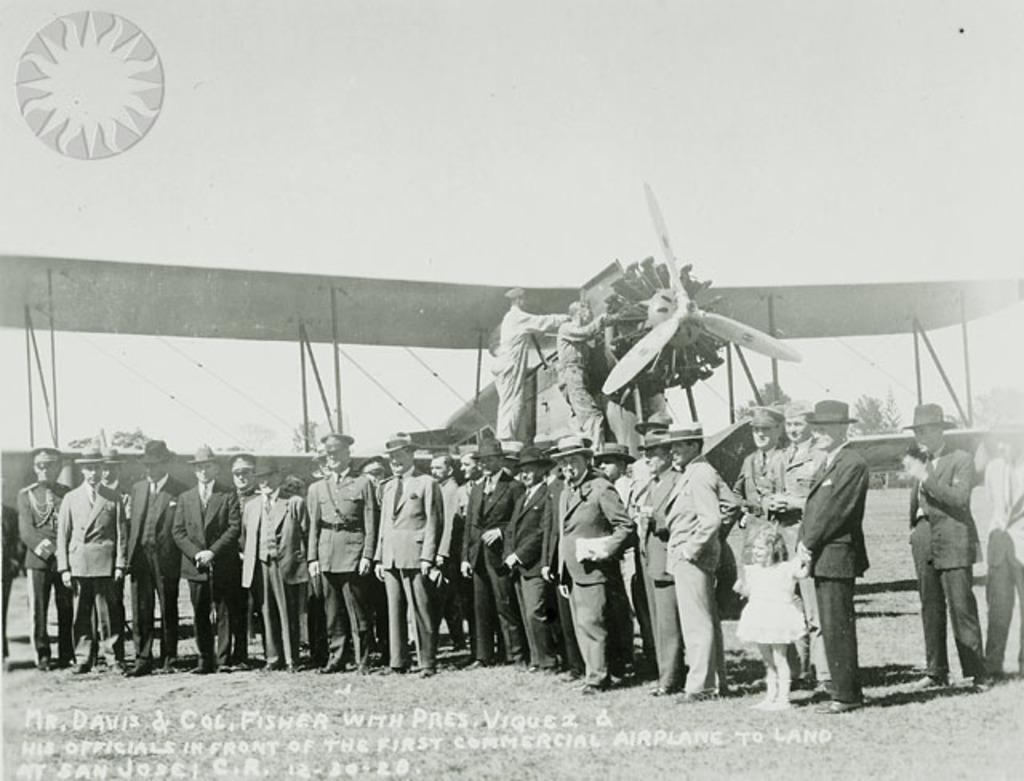<image>
Share a concise interpretation of the image provided. Several men are standing in front of a plane, include Mr. Davis. 